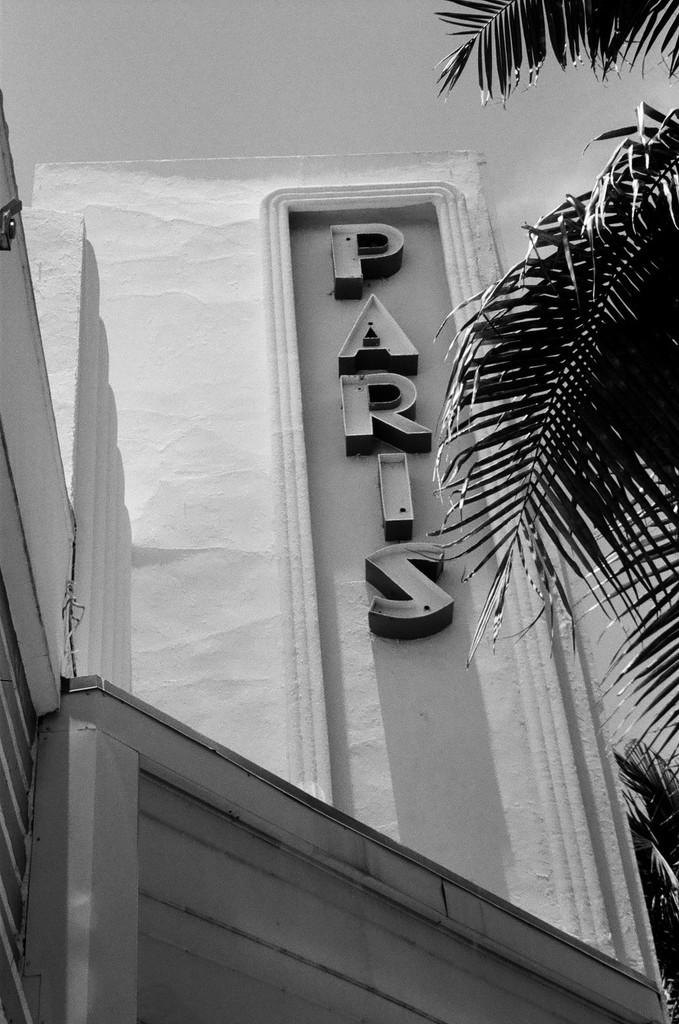What type of photo is in the image? The image contains a black and white photo of a building. What is written on the building in the photo? The word "Paris" is written on the building. What can be seen in the right corner of the image? There is a coconut tree in the right corner of the image. What type of fruit is being used to ask a question in the image? There is no fruit being used to ask a question in the image. Can you see a pear forming a circle in the image? There is no pear or circle present in the image. 